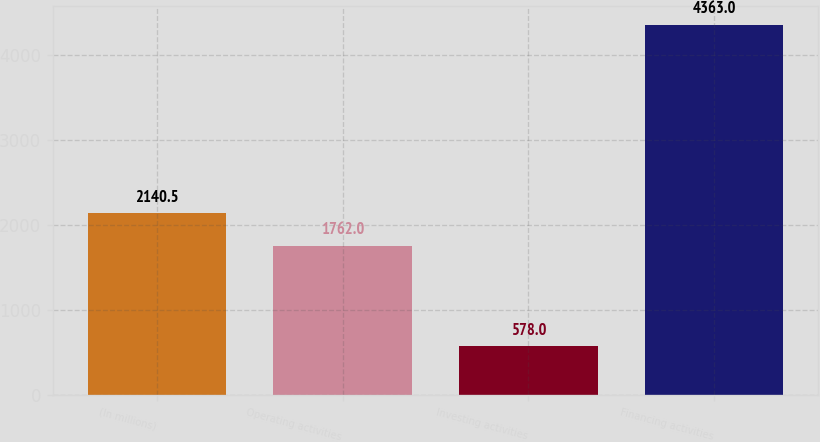Convert chart to OTSL. <chart><loc_0><loc_0><loc_500><loc_500><bar_chart><fcel>(In millions)<fcel>Operating activities<fcel>Investing activities<fcel>Financing activities<nl><fcel>2140.5<fcel>1762<fcel>578<fcel>4363<nl></chart> 